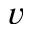Convert formula to latex. <formula><loc_0><loc_0><loc_500><loc_500>v</formula> 